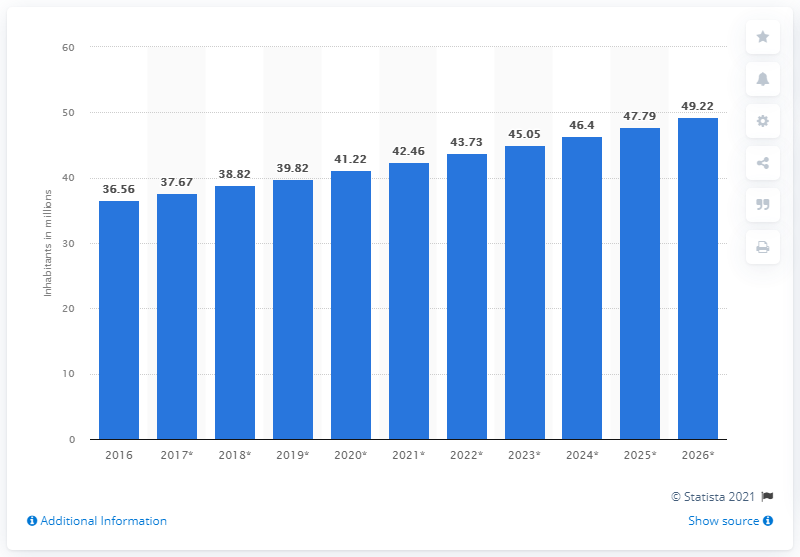Specify some key components in this picture. As of 2020, Uganda's population was estimated to be 41.22 million people. 